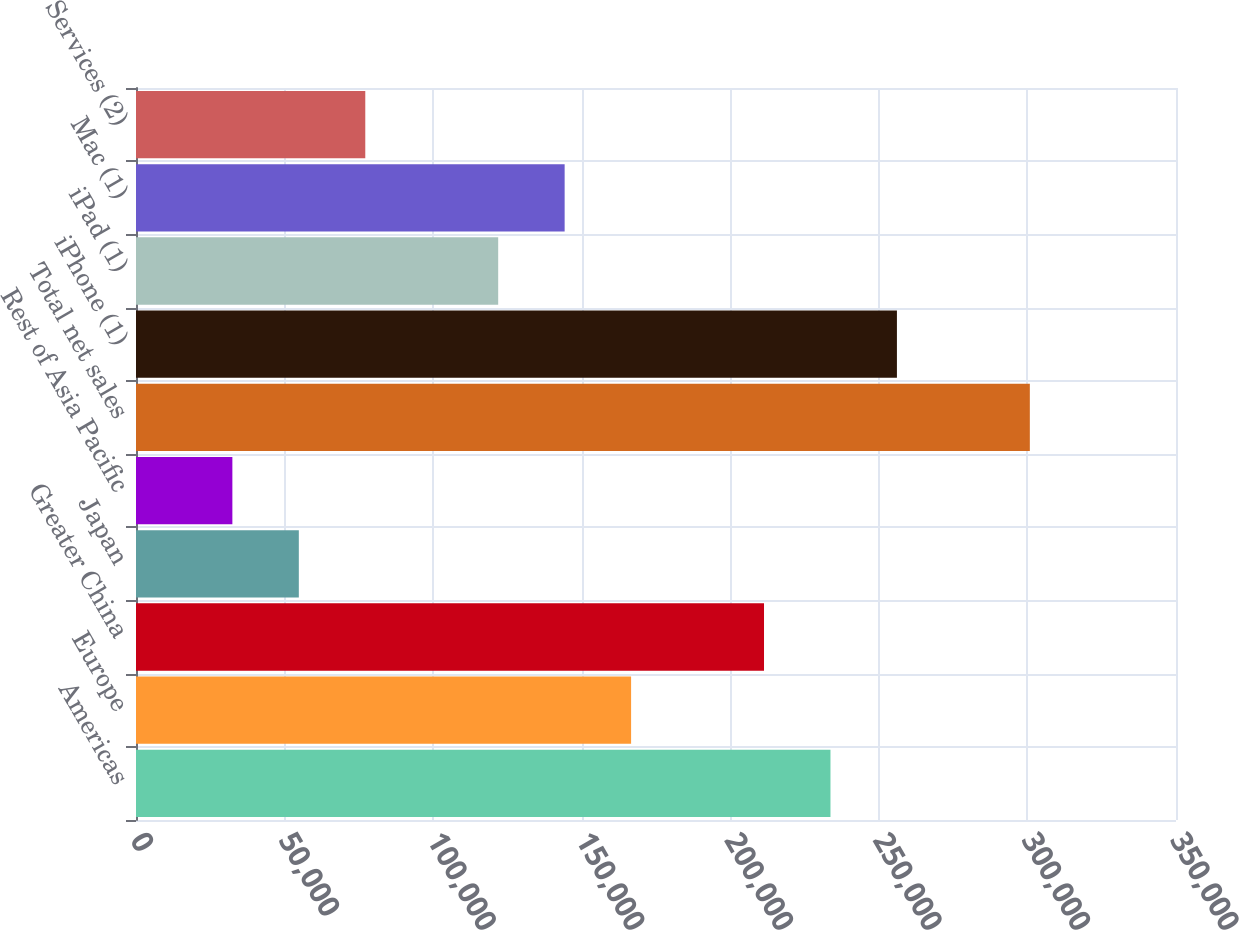Convert chart to OTSL. <chart><loc_0><loc_0><loc_500><loc_500><bar_chart><fcel>Americas<fcel>Europe<fcel>Greater China<fcel>Japan<fcel>Rest of Asia Pacific<fcel>Total net sales<fcel>iPhone (1)<fcel>iPad (1)<fcel>Mac (1)<fcel>Services (2)<nl><fcel>233715<fcel>166621<fcel>211350<fcel>54796.6<fcel>32431.8<fcel>300809<fcel>256080<fcel>121891<fcel>144256<fcel>77161.4<nl></chart> 